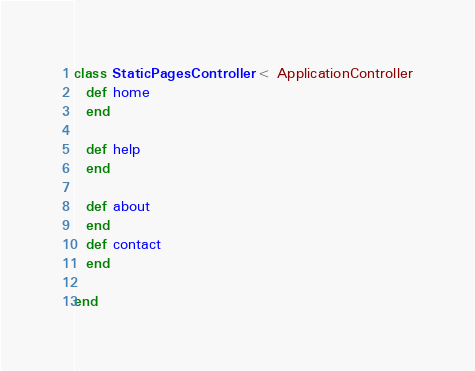<code> <loc_0><loc_0><loc_500><loc_500><_Ruby_>class StaticPagesController < ApplicationController
  def home
  end

  def help
  end
  
  def about
  end
  def contact
  end
  
end
</code> 